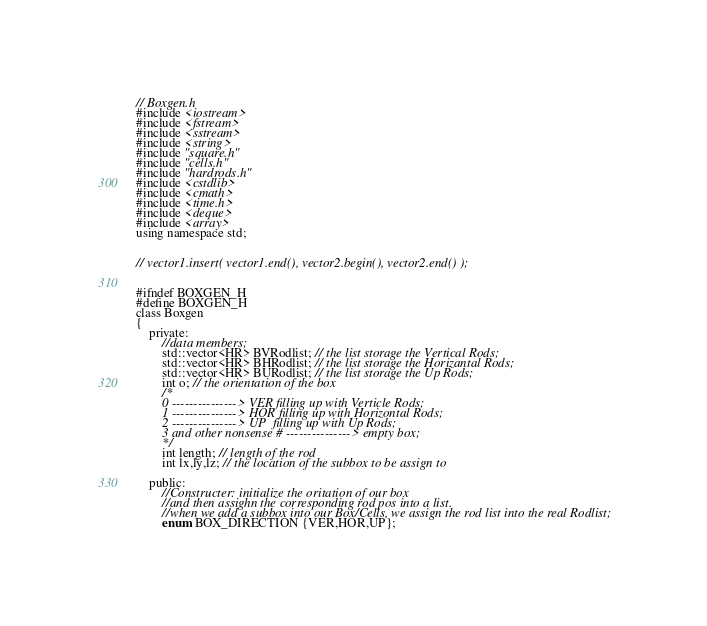<code> <loc_0><loc_0><loc_500><loc_500><_C_>// Boxgen.h
#include <iostream>
#include <fstream>
#include <sstream>
#include <string>
#include "square.h"
#include "cells.h"
#include "hardrods.h"
#include <cstdlib>
#include <cmath>
#include <time.h>
#include <deque>
#include <array>
using namespace std;


// vector1.insert( vector1.end(), vector2.begin(), vector2.end() );


#ifndef BOXGEN_H
#define BOXGEN_H
class Boxgen
{
    private:
    	//data members;
        std::vector<HR> BVRodlist; // the list storage the Vertical Rods;
        std::vector<HR> BHRodlist; // the list storage the Horizantal Rods;
        std::vector<HR> BURodlist; // the list storage the Up Rods;
        int o; // the orientation of the box 
        /*
        0 ---------------> VER filling up with Verticle Rods;
        1 ---------------> HOR filling up with Horizontal Rods;
        2 ---------------> UP  filling up with Up Rods;
        3 and other nonsense # ---------------> empty box;
        */
    	int length; // length of the rod
        int lx,ly,lz; // the location of the subbox to be assign to
       
    public:
        //Constructer: initialize the oritation of our box
        //and then assighn the corresponding rod pos into a list.
        //when we add a subbox into our Box/Cells, we assign the rod list into the real Rodlist;
        enum BOX_DIRECTION {VER,HOR,UP};
</code> 